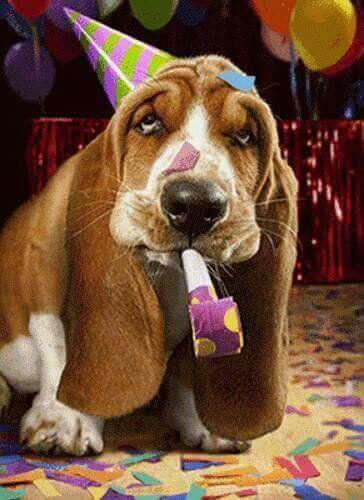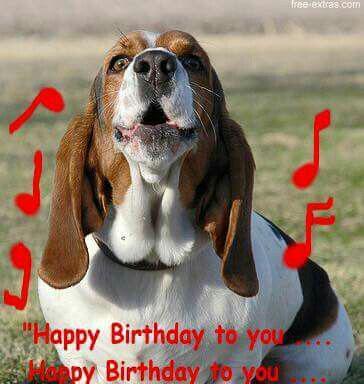The first image is the image on the left, the second image is the image on the right. Given the left and right images, does the statement "The dog in at least one of the images is outside." hold true? Answer yes or no. Yes. The first image is the image on the left, the second image is the image on the right. For the images shown, is this caption "One of the dogs is wearing a birthday hat." true? Answer yes or no. Yes. 